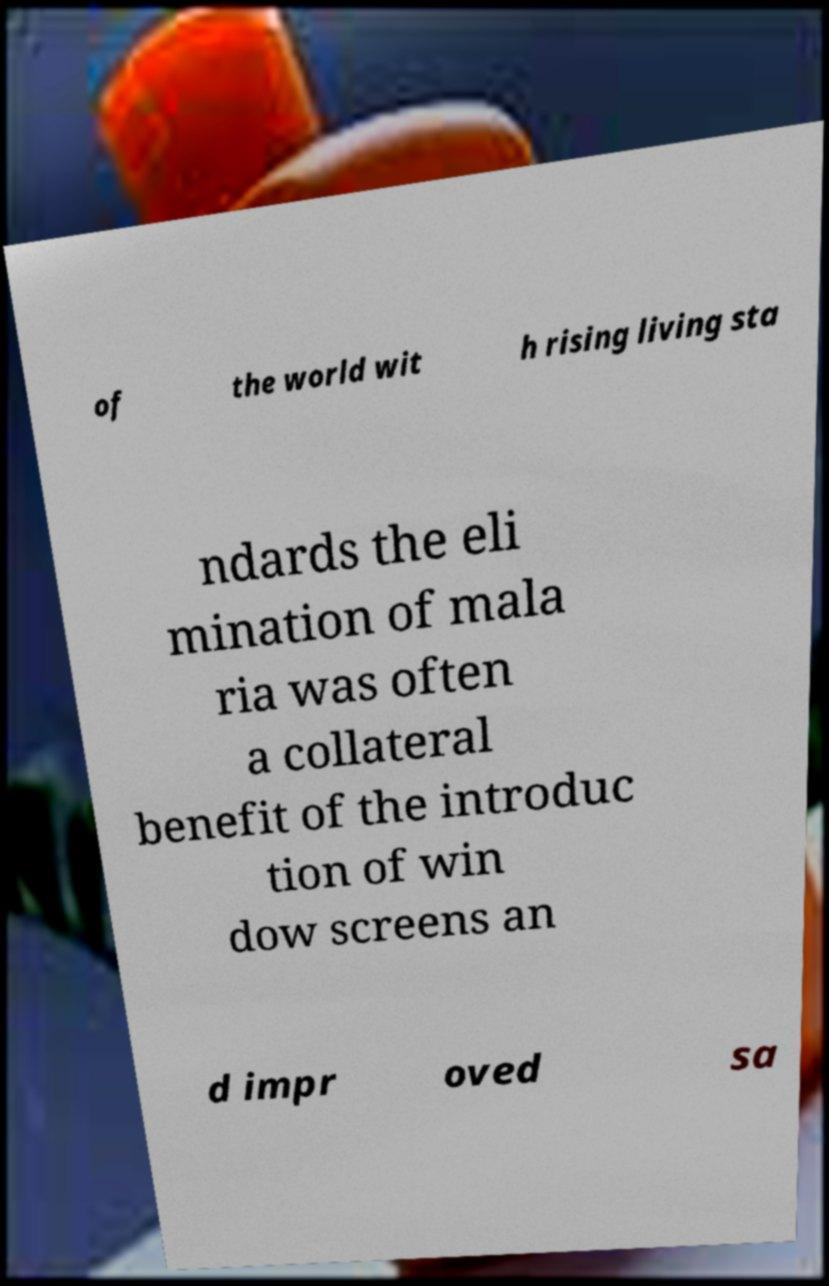For documentation purposes, I need the text within this image transcribed. Could you provide that? of the world wit h rising living sta ndards the eli mination of mala ria was often a collateral benefit of the introduc tion of win dow screens an d impr oved sa 